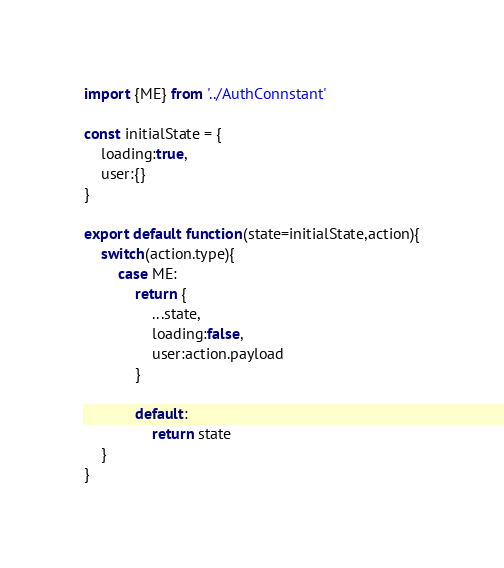Convert code to text. <code><loc_0><loc_0><loc_500><loc_500><_JavaScript_>import {ME} from '../AuthConnstant'

const initialState = {
    loading:true,
    user:{}
}

export default function(state=initialState,action){
    switch(action.type){
        case ME:
            return {
                ...state,
                loading:false,
                user:action.payload
            }

            default:
                return state
    }
}</code> 